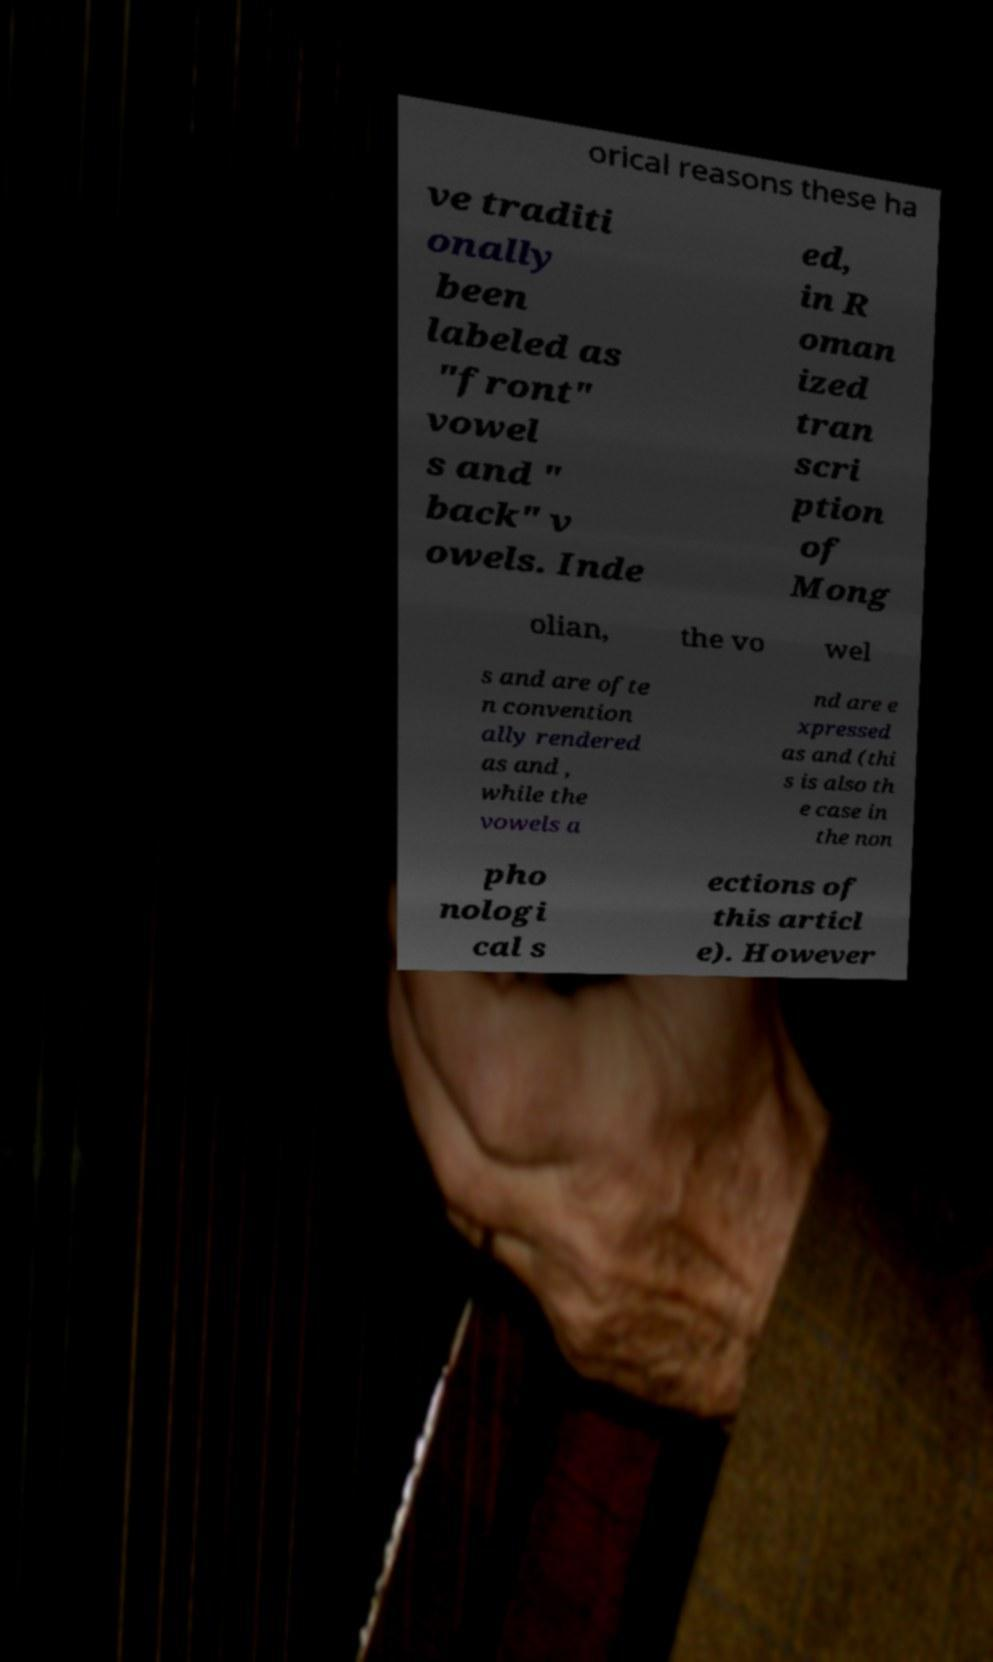Can you read and provide the text displayed in the image?This photo seems to have some interesting text. Can you extract and type it out for me? orical reasons these ha ve traditi onally been labeled as "front" vowel s and " back" v owels. Inde ed, in R oman ized tran scri ption of Mong olian, the vo wel s and are ofte n convention ally rendered as and , while the vowels a nd are e xpressed as and (thi s is also th e case in the non pho nologi cal s ections of this articl e). However 